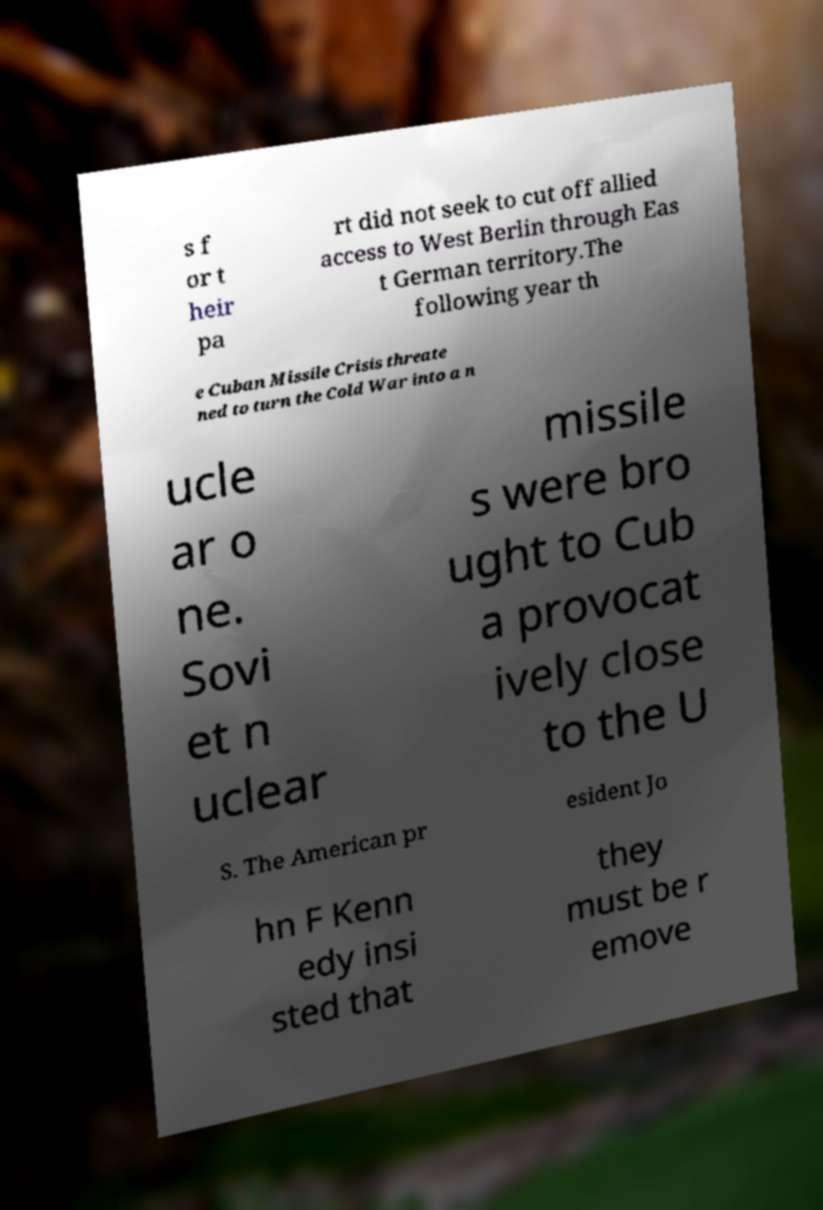Can you accurately transcribe the text from the provided image for me? s f or t heir pa rt did not seek to cut off allied access to West Berlin through Eas t German territory.The following year th e Cuban Missile Crisis threate ned to turn the Cold War into a n ucle ar o ne. Sovi et n uclear missile s were bro ught to Cub a provocat ively close to the U S. The American pr esident Jo hn F Kenn edy insi sted that they must be r emove 